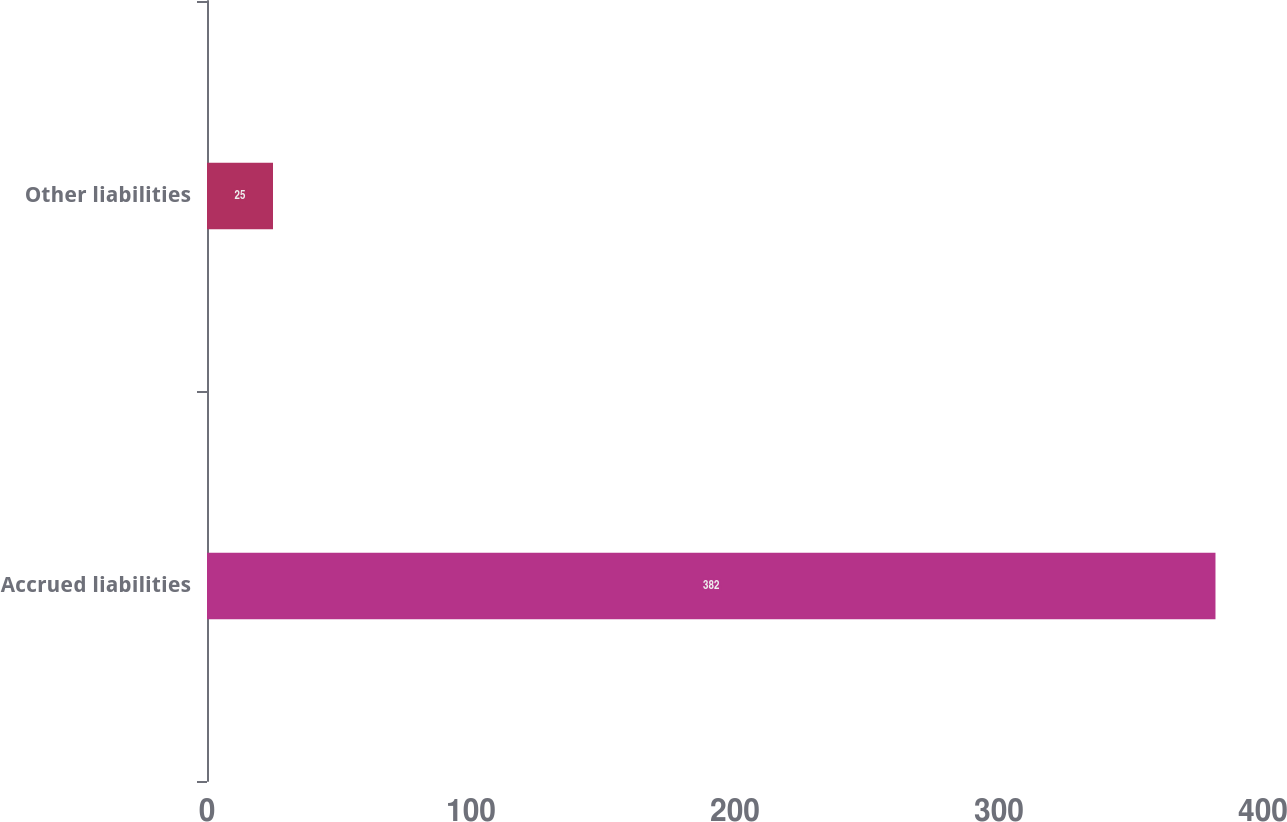Convert chart. <chart><loc_0><loc_0><loc_500><loc_500><bar_chart><fcel>Accrued liabilities<fcel>Other liabilities<nl><fcel>382<fcel>25<nl></chart> 